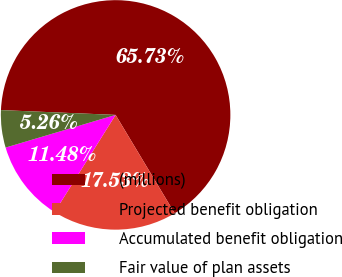Convert chart to OTSL. <chart><loc_0><loc_0><loc_500><loc_500><pie_chart><fcel>(millions)<fcel>Projected benefit obligation<fcel>Accumulated benefit obligation<fcel>Fair value of plan assets<nl><fcel>65.72%<fcel>17.53%<fcel>11.48%<fcel>5.26%<nl></chart> 